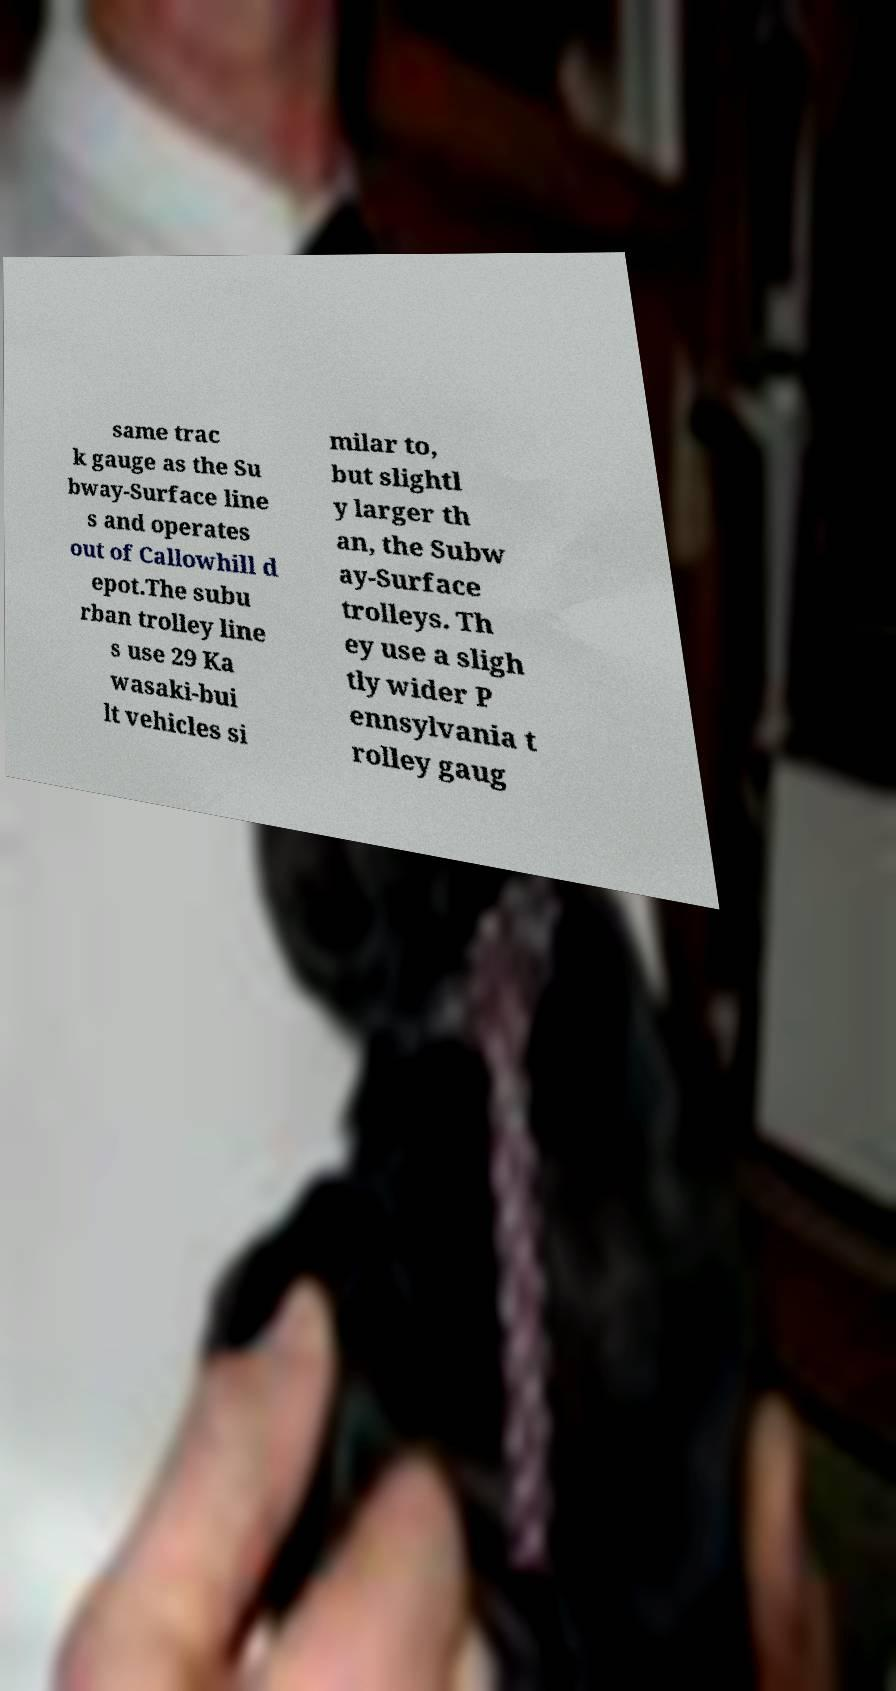Please read and relay the text visible in this image. What does it say? same trac k gauge as the Su bway-Surface line s and operates out of Callowhill d epot.The subu rban trolley line s use 29 Ka wasaki-bui lt vehicles si milar to, but slightl y larger th an, the Subw ay-Surface trolleys. Th ey use a sligh tly wider P ennsylvania t rolley gaug 